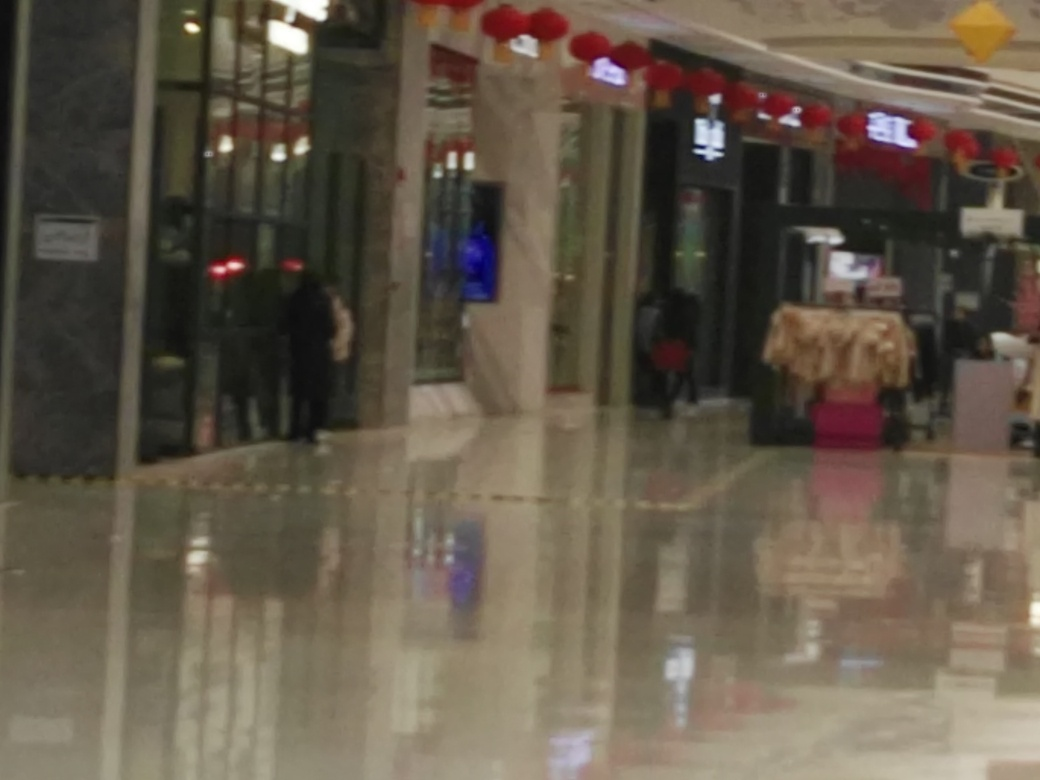Can you describe the setting of this image? The image appears to depict an indoor commercial setting, possibly a shopping mall or a retail space. There are decorative elements like red lanterns hanging from the ceiling, suggesting that it might be during a festive period or celebration. Some shops and kiosks are visible, along with reflective flooring that provides a clear, albeit blurry, reflection of the surroundings and few individuals can be seen in the distance. 